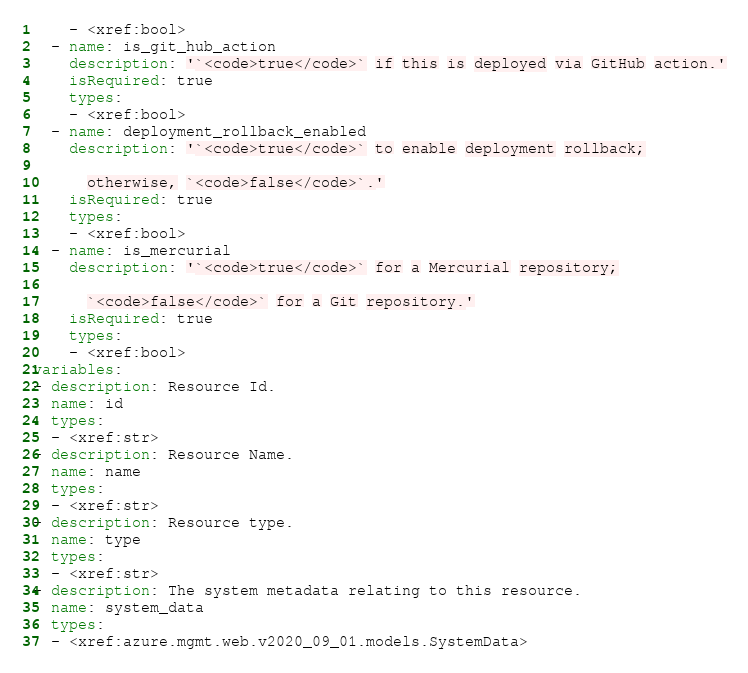<code> <loc_0><loc_0><loc_500><loc_500><_YAML_>    - <xref:bool>
  - name: is_git_hub_action
    description: '`<code>true</code>` if this is deployed via GitHub action.'
    isRequired: true
    types:
    - <xref:bool>
  - name: deployment_rollback_enabled
    description: '`<code>true</code>` to enable deployment rollback;

      otherwise, `<code>false</code>`.'
    isRequired: true
    types:
    - <xref:bool>
  - name: is_mercurial
    description: '`<code>true</code>` for a Mercurial repository;

      `<code>false</code>` for a Git repository.'
    isRequired: true
    types:
    - <xref:bool>
variables:
- description: Resource Id.
  name: id
  types:
  - <xref:str>
- description: Resource Name.
  name: name
  types:
  - <xref:str>
- description: Resource type.
  name: type
  types:
  - <xref:str>
- description: The system metadata relating to this resource.
  name: system_data
  types:
  - <xref:azure.mgmt.web.v2020_09_01.models.SystemData>
</code> 